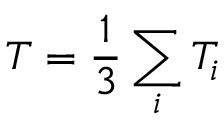<formula> <loc_0><loc_0><loc_500><loc_500>T = \frac { 1 } { 3 } \sum _ { i } T _ { i }</formula> 